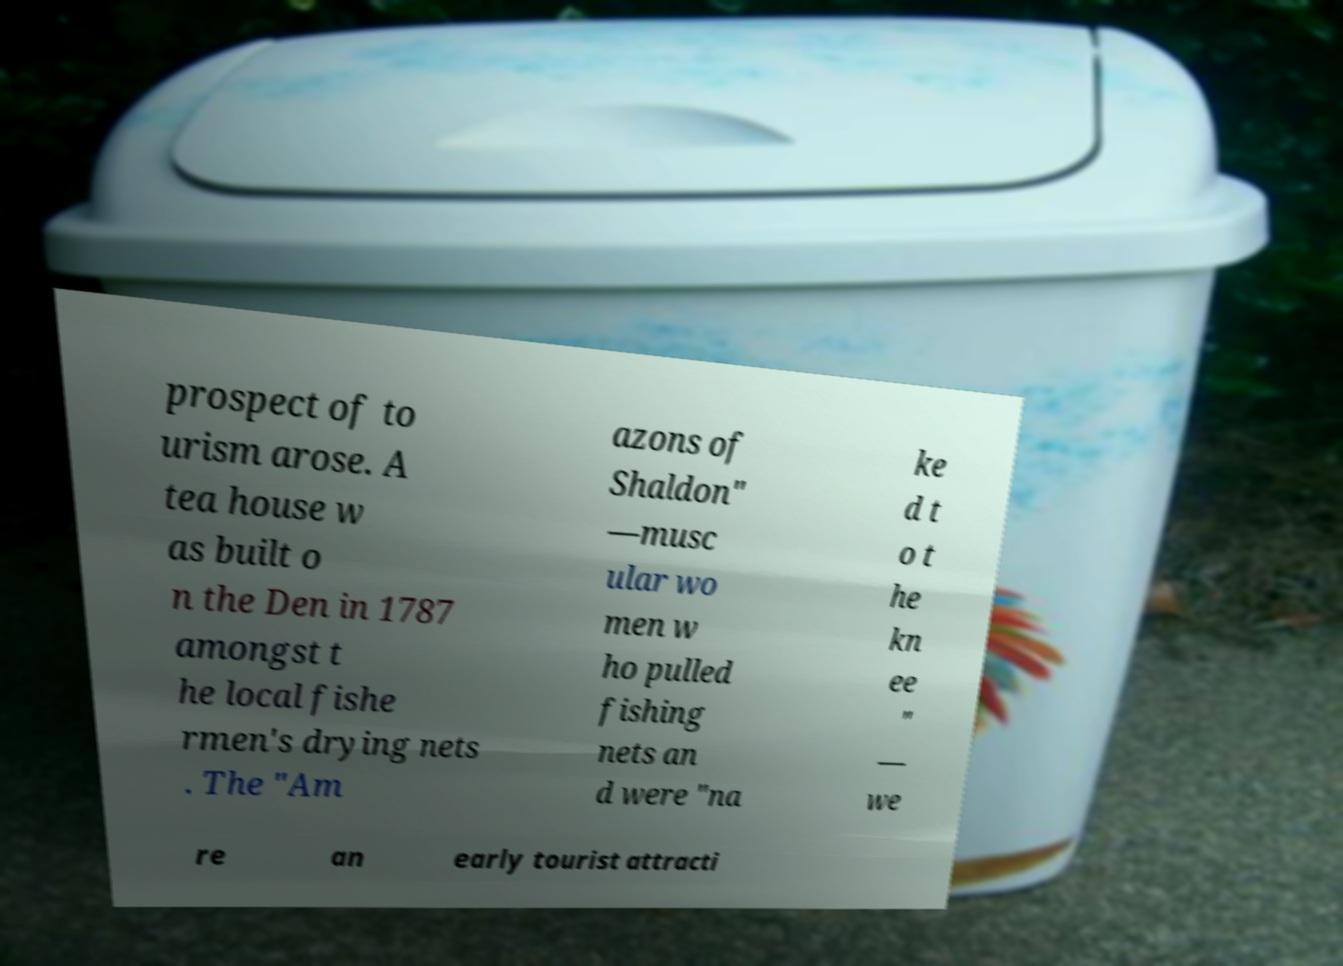For documentation purposes, I need the text within this image transcribed. Could you provide that? prospect of to urism arose. A tea house w as built o n the Den in 1787 amongst t he local fishe rmen's drying nets . The "Am azons of Shaldon" —musc ular wo men w ho pulled fishing nets an d were "na ke d t o t he kn ee " — we re an early tourist attracti 